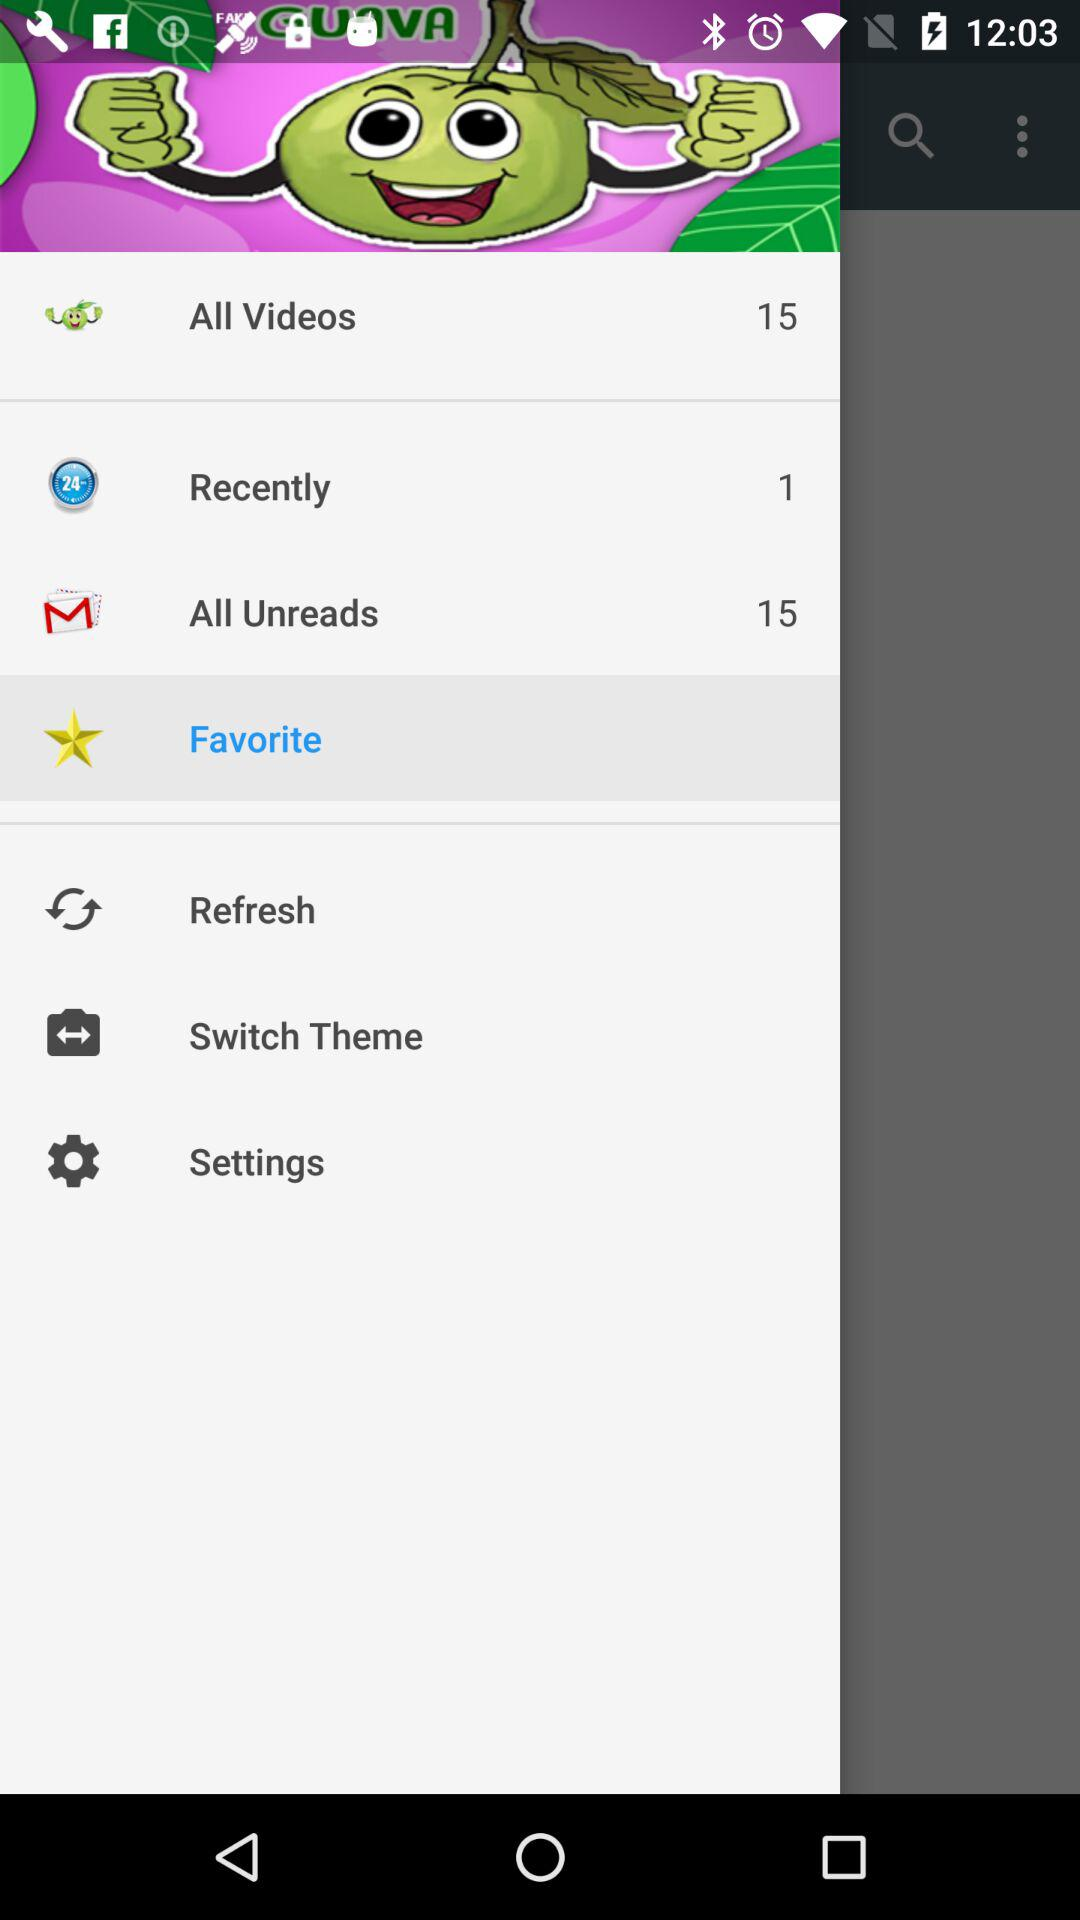How many unread emails are there? There are 15 unread emails. 